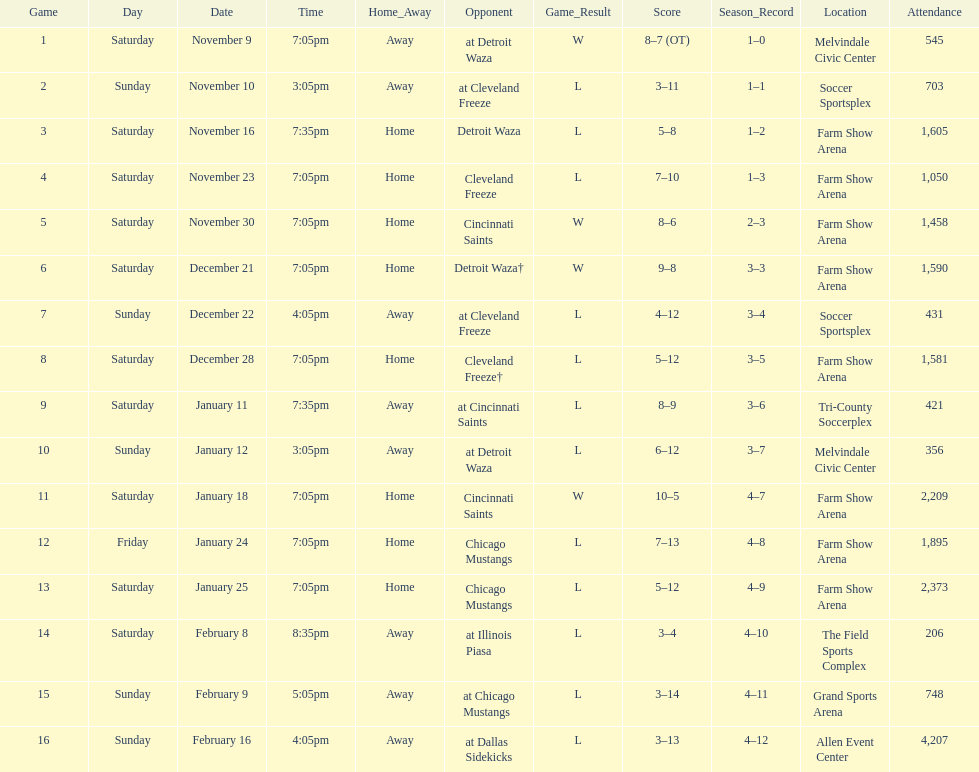How long was the teams longest losing streak? 5 games. Parse the full table. {'header': ['Game', 'Day', 'Date', 'Time', 'Home_Away', 'Opponent', 'Game_Result', 'Score', 'Season_Record', 'Location', 'Attendance'], 'rows': [['1', 'Saturday', 'November 9', '7:05pm', 'Away', 'at Detroit Waza', 'W', '8–7 (OT)', '1–0', 'Melvindale Civic Center', '545'], ['2', 'Sunday', 'November 10', '3:05pm', 'Away', 'at Cleveland Freeze', 'L', '3–11', '1–1', 'Soccer Sportsplex', '703'], ['3', 'Saturday', 'November 16', '7:35pm', 'Home', 'Detroit Waza', 'L', '5–8', '1–2', 'Farm Show Arena', '1,605'], ['4', 'Saturday', 'November 23', '7:05pm', 'Home', 'Cleveland Freeze', 'L', '7–10', '1–3', 'Farm Show Arena', '1,050'], ['5', 'Saturday', 'November 30', '7:05pm', 'Home', 'Cincinnati Saints', 'W', '8–6', '2–3', 'Farm Show Arena', '1,458'], ['6', 'Saturday', 'December 21', '7:05pm', 'Home', 'Detroit Waza†', 'W', '9–8', '3–3', 'Farm Show Arena', '1,590'], ['7', 'Sunday', 'December 22', '4:05pm', 'Away', 'at Cleveland Freeze', 'L', '4–12', '3–4', 'Soccer Sportsplex', '431'], ['8', 'Saturday', 'December 28', '7:05pm', 'Home', 'Cleveland Freeze†', 'L', '5–12', '3–5', 'Farm Show Arena', '1,581'], ['9', 'Saturday', 'January 11', '7:35pm', 'Away', 'at Cincinnati Saints', 'L', '8–9', '3–6', 'Tri-County Soccerplex', '421'], ['10', 'Sunday', 'January 12', '3:05pm', 'Away', 'at Detroit Waza', 'L', '6–12', '3–7', 'Melvindale Civic Center', '356'], ['11', 'Saturday', 'January 18', '7:05pm', 'Home', 'Cincinnati Saints', 'W', '10–5', '4–7', 'Farm Show Arena', '2,209'], ['12', 'Friday', 'January 24', '7:05pm', 'Home', 'Chicago Mustangs', 'L', '7–13', '4–8', 'Farm Show Arena', '1,895'], ['13', 'Saturday', 'January 25', '7:05pm', 'Home', 'Chicago Mustangs', 'L', '5–12', '4–9', 'Farm Show Arena', '2,373'], ['14', 'Saturday', 'February 8', '8:35pm', 'Away', 'at Illinois Piasa', 'L', '3–4', '4–10', 'The Field Sports Complex', '206'], ['15', 'Sunday', 'February 9', '5:05pm', 'Away', 'at Chicago Mustangs', 'L', '3–14', '4–11', 'Grand Sports Arena', '748'], ['16', 'Sunday', 'February 16', '4:05pm', 'Away', 'at Dallas Sidekicks', 'L', '3–13', '4–12', 'Allen Event Center', '4,207']]} 